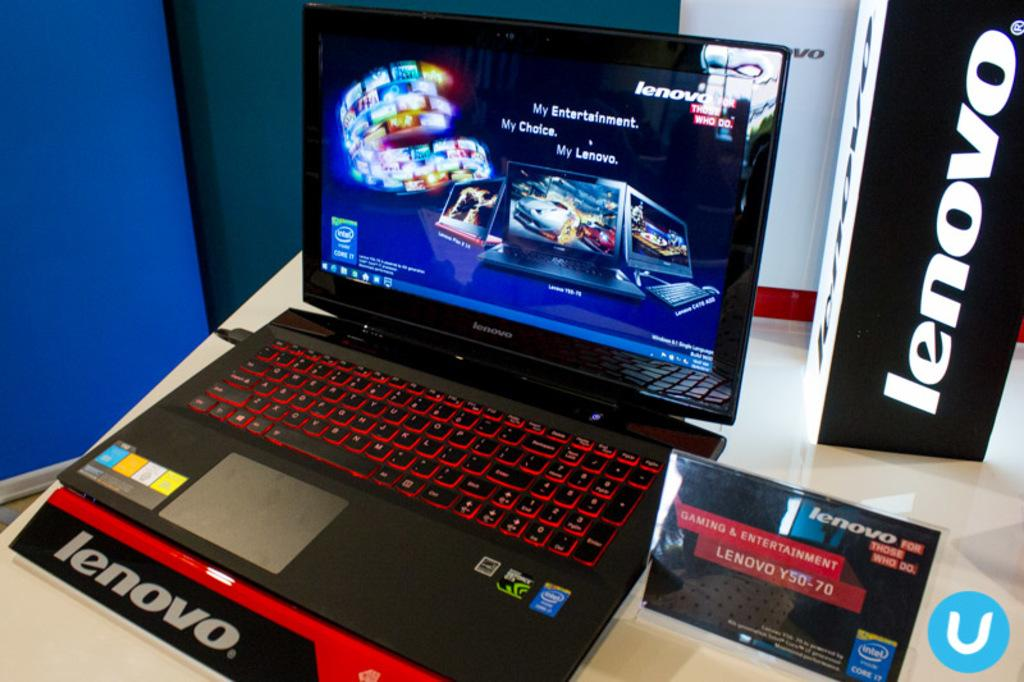<image>
Share a concise interpretation of the image provided. A laptop with Lenovo markings near it and a game on the screen. 